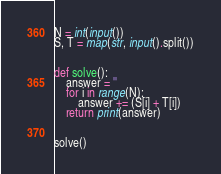<code> <loc_0><loc_0><loc_500><loc_500><_Python_>N = int(input())
S, T = map(str, input().split())


def solve():
    answer = ''
    for i in range(N):
        answer += (S[i] + T[i])
    return print(answer)


solve()
</code> 